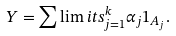Convert formula to latex. <formula><loc_0><loc_0><loc_500><loc_500>Y = \sum \lim i t s _ { j = 1 } ^ { k } \alpha _ { j } 1 _ { A _ { j } } .</formula> 